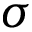<formula> <loc_0><loc_0><loc_500><loc_500>\sigma</formula> 